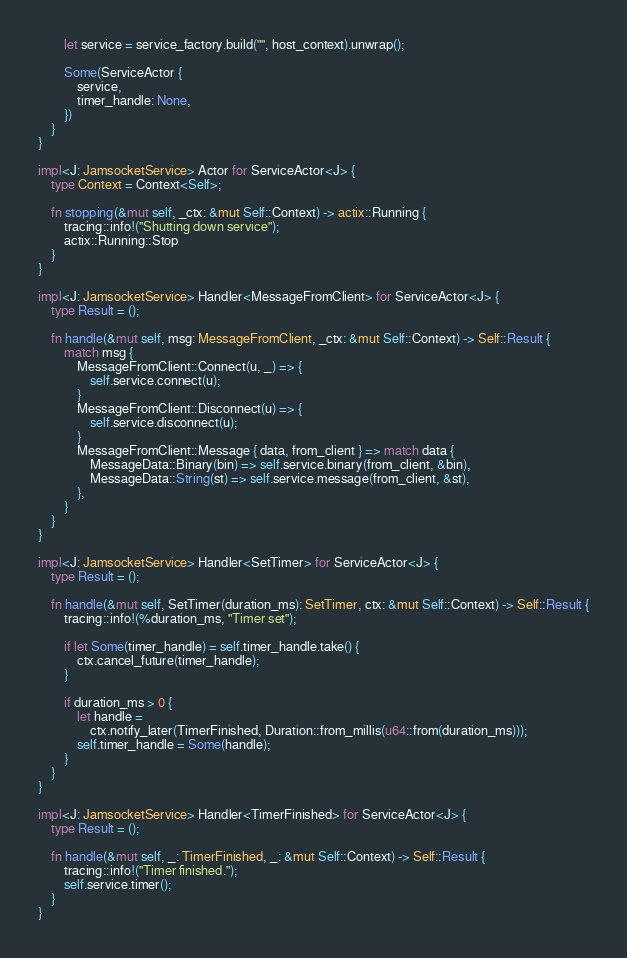Convert code to text. <code><loc_0><loc_0><loc_500><loc_500><_Rust_>
        let service = service_factory.build("", host_context).unwrap();

        Some(ServiceActor {
            service,
            timer_handle: None,
        })
    }
}

impl<J: JamsocketService> Actor for ServiceActor<J> {
    type Context = Context<Self>;

    fn stopping(&mut self, _ctx: &mut Self::Context) -> actix::Running {
        tracing::info!("Shutting down service");
        actix::Running::Stop
    }
}

impl<J: JamsocketService> Handler<MessageFromClient> for ServiceActor<J> {
    type Result = ();

    fn handle(&mut self, msg: MessageFromClient, _ctx: &mut Self::Context) -> Self::Result {
        match msg {
            MessageFromClient::Connect(u, _) => {
                self.service.connect(u);
            }
            MessageFromClient::Disconnect(u) => {
                self.service.disconnect(u);
            }
            MessageFromClient::Message { data, from_client } => match data {
                MessageData::Binary(bin) => self.service.binary(from_client, &bin),
                MessageData::String(st) => self.service.message(from_client, &st),
            },
        }
    }
}

impl<J: JamsocketService> Handler<SetTimer> for ServiceActor<J> {
    type Result = ();

    fn handle(&mut self, SetTimer(duration_ms): SetTimer, ctx: &mut Self::Context) -> Self::Result {
        tracing::info!(%duration_ms, "Timer set");

        if let Some(timer_handle) = self.timer_handle.take() {
            ctx.cancel_future(timer_handle);
        }

        if duration_ms > 0 {
            let handle =
                ctx.notify_later(TimerFinished, Duration::from_millis(u64::from(duration_ms)));
            self.timer_handle = Some(handle);
        }
    }
}

impl<J: JamsocketService> Handler<TimerFinished> for ServiceActor<J> {
    type Result = ();

    fn handle(&mut self, _: TimerFinished, _: &mut Self::Context) -> Self::Result {
        tracing::info!("Timer finished.");
        self.service.timer();
    }
}
</code> 